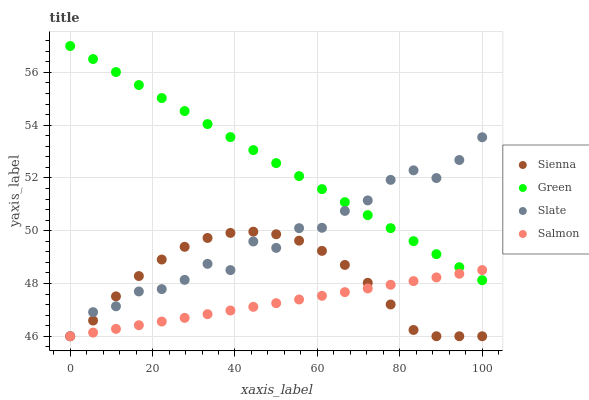Does Salmon have the minimum area under the curve?
Answer yes or no. Yes. Does Green have the maximum area under the curve?
Answer yes or no. Yes. Does Slate have the minimum area under the curve?
Answer yes or no. No. Does Slate have the maximum area under the curve?
Answer yes or no. No. Is Salmon the smoothest?
Answer yes or no. Yes. Is Slate the roughest?
Answer yes or no. Yes. Is Slate the smoothest?
Answer yes or no. No. Is Salmon the roughest?
Answer yes or no. No. Does Sienna have the lowest value?
Answer yes or no. Yes. Does Green have the lowest value?
Answer yes or no. No. Does Green have the highest value?
Answer yes or no. Yes. Does Slate have the highest value?
Answer yes or no. No. Is Sienna less than Green?
Answer yes or no. Yes. Is Green greater than Sienna?
Answer yes or no. Yes. Does Slate intersect Sienna?
Answer yes or no. Yes. Is Slate less than Sienna?
Answer yes or no. No. Is Slate greater than Sienna?
Answer yes or no. No. Does Sienna intersect Green?
Answer yes or no. No. 